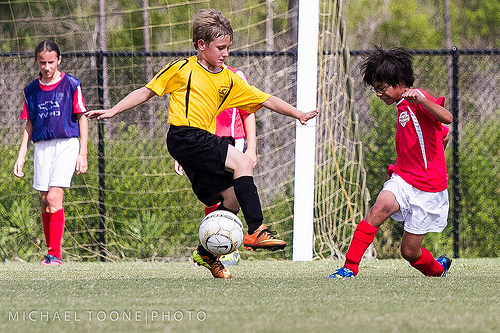<image>
Is the boy on the ball? No. The boy is not positioned on the ball. They may be near each other, but the boy is not supported by or resting on top of the ball. 